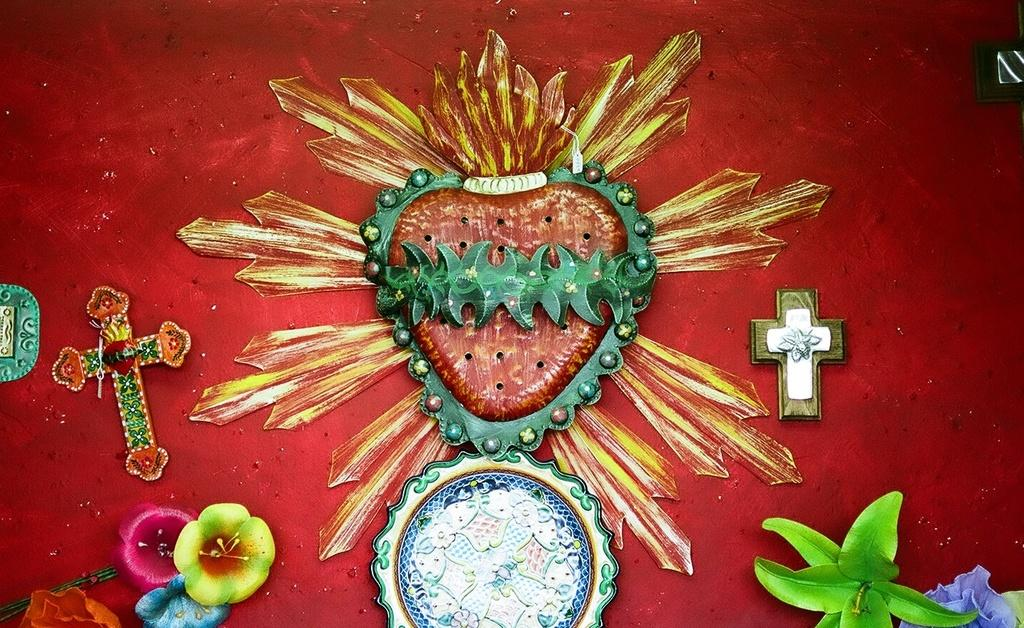What type of art is featured in the image? There is wall design art in the image. Are there any specific symbols or themes in the art? Yes, there are Christianity symbols in the image. What type of bait is used to attract the kitty in the image? There is no kitty or bait present in the image; it features wall design art with Christianity symbols. What color is the lipstick on the person in the image? There is no person or lipstick present in the image; it only features wall design art with Christianity symbols. 